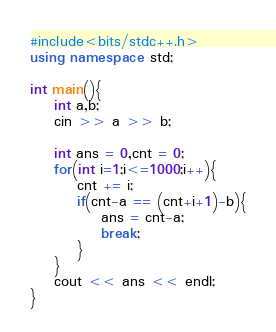Convert code to text. <code><loc_0><loc_0><loc_500><loc_500><_C++_>#include<bits/stdc++.h>
using namespace std;

int main(){
    int a,b;
    cin >> a >> b;

    int ans = 0,cnt = 0;
    for(int i=1;i<=1000;i++){
        cnt += i;
        if(cnt-a == (cnt+i+1)-b){
            ans = cnt-a;
            break;
        }
    }
    cout << ans << endl;
}
</code> 